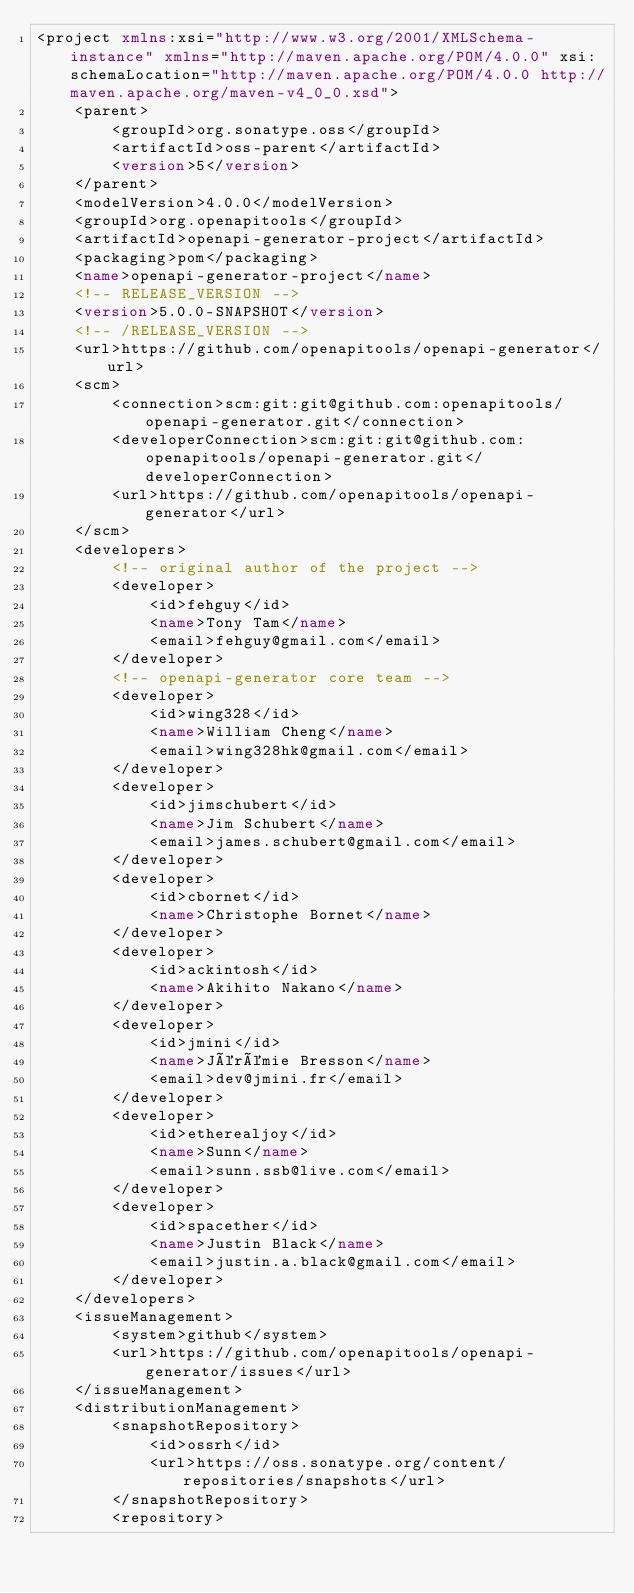<code> <loc_0><loc_0><loc_500><loc_500><_XML_><project xmlns:xsi="http://www.w3.org/2001/XMLSchema-instance" xmlns="http://maven.apache.org/POM/4.0.0" xsi:schemaLocation="http://maven.apache.org/POM/4.0.0 http://maven.apache.org/maven-v4_0_0.xsd">
    <parent>
        <groupId>org.sonatype.oss</groupId>
        <artifactId>oss-parent</artifactId>
        <version>5</version>
    </parent>
    <modelVersion>4.0.0</modelVersion>
    <groupId>org.openapitools</groupId>
    <artifactId>openapi-generator-project</artifactId>
    <packaging>pom</packaging>
    <name>openapi-generator-project</name>
    <!-- RELEASE_VERSION -->
    <version>5.0.0-SNAPSHOT</version>
    <!-- /RELEASE_VERSION -->
    <url>https://github.com/openapitools/openapi-generator</url>
    <scm>
        <connection>scm:git:git@github.com:openapitools/openapi-generator.git</connection>
        <developerConnection>scm:git:git@github.com:openapitools/openapi-generator.git</developerConnection>
        <url>https://github.com/openapitools/openapi-generator</url>
    </scm>
    <developers>
        <!-- original author of the project -->
        <developer>
            <id>fehguy</id>
            <name>Tony Tam</name>
            <email>fehguy@gmail.com</email>
        </developer>
        <!-- openapi-generator core team -->
        <developer>
            <id>wing328</id>
            <name>William Cheng</name>
            <email>wing328hk@gmail.com</email>
        </developer>
        <developer>
            <id>jimschubert</id>
            <name>Jim Schubert</name>
            <email>james.schubert@gmail.com</email>
        </developer>
        <developer>
            <id>cbornet</id>
            <name>Christophe Bornet</name>
        </developer>
        <developer>
            <id>ackintosh</id>
            <name>Akihito Nakano</name>
        </developer>
        <developer>
            <id>jmini</id>
            <name>Jérémie Bresson</name>
            <email>dev@jmini.fr</email>
        </developer>
        <developer>
            <id>etherealjoy</id>
            <name>Sunn</name>
            <email>sunn.ssb@live.com</email>
        </developer>
        <developer>
            <id>spacether</id>
            <name>Justin Black</name>
            <email>justin.a.black@gmail.com</email>
        </developer>
    </developers>
    <issueManagement>
        <system>github</system>
        <url>https://github.com/openapitools/openapi-generator/issues</url>
    </issueManagement>
    <distributionManagement>
        <snapshotRepository>
            <id>ossrh</id>
            <url>https://oss.sonatype.org/content/repositories/snapshots</url>
        </snapshotRepository>
        <repository></code> 